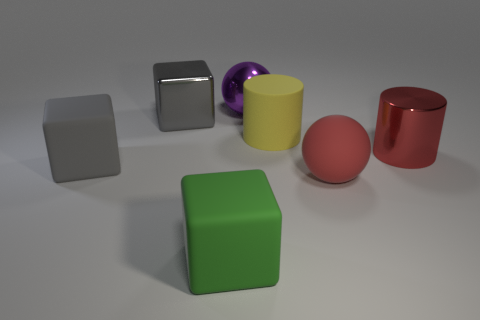How would the scene be different if the lighting was coming from the opposite direction? If the lighting came from the opposite direction, the shadows would be cast toward us, highlighting different contours and edges of the objects, possibly altering the appearance of their colors and textures due to the change in illumination. Could you describe the potential changes in the appearance of the purple object under such lighting conditions? The purple object, with its glossy surface, would likely display a more dramatic reflection and enhanced specular highlights. The shift in lighting could reveal new details or accentuate its curvature differently. 